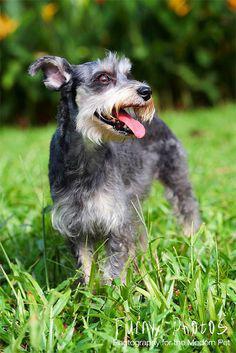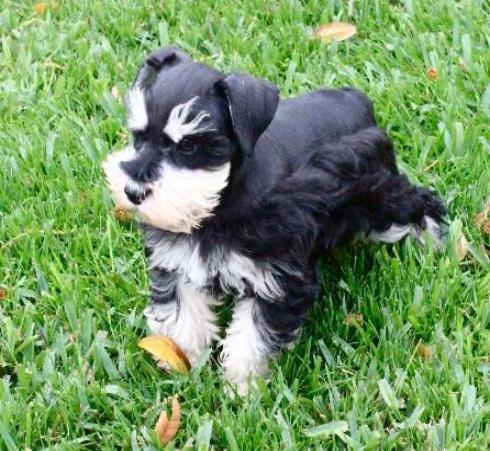The first image is the image on the left, the second image is the image on the right. Given the left and right images, does the statement "A dog's collar is visible." hold true? Answer yes or no. No. 